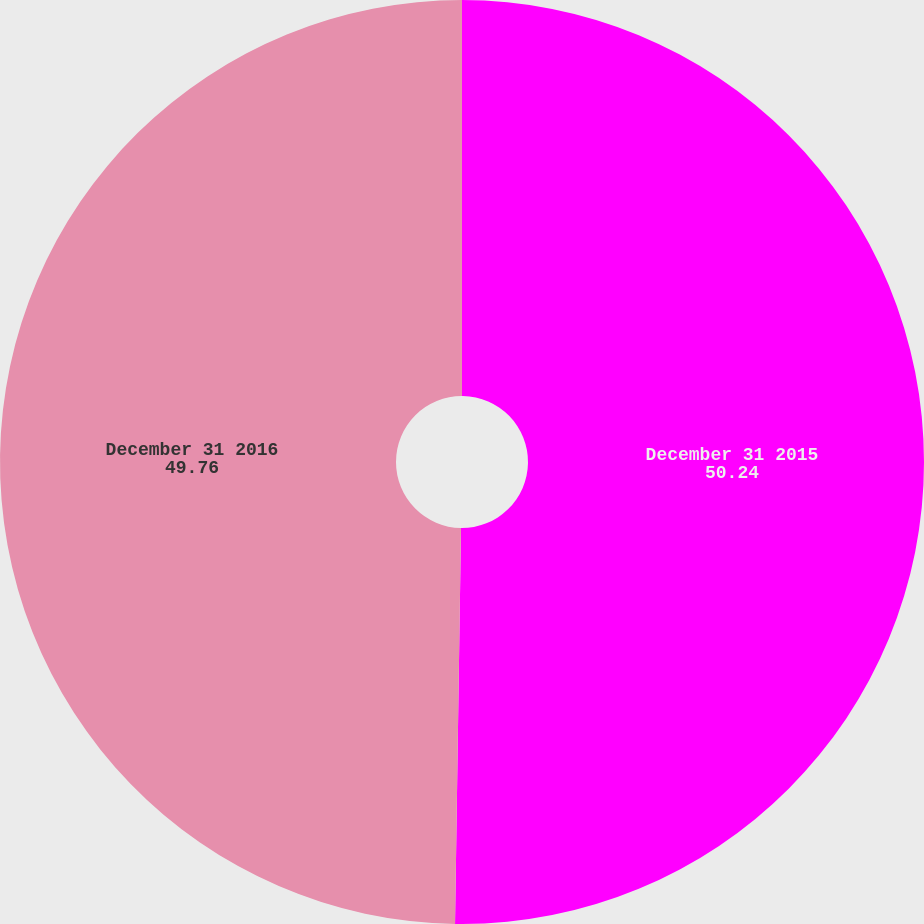<chart> <loc_0><loc_0><loc_500><loc_500><pie_chart><fcel>December 31 2015<fcel>December 31 2016<nl><fcel>50.24%<fcel>49.76%<nl></chart> 